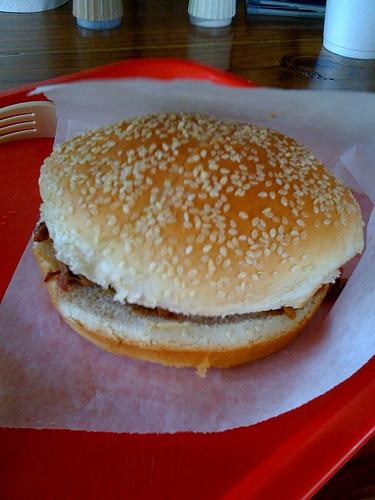What is on top of the bun?

Choices:
A) seeds
B) cheese
C) ketchup
D) nachos seeds 